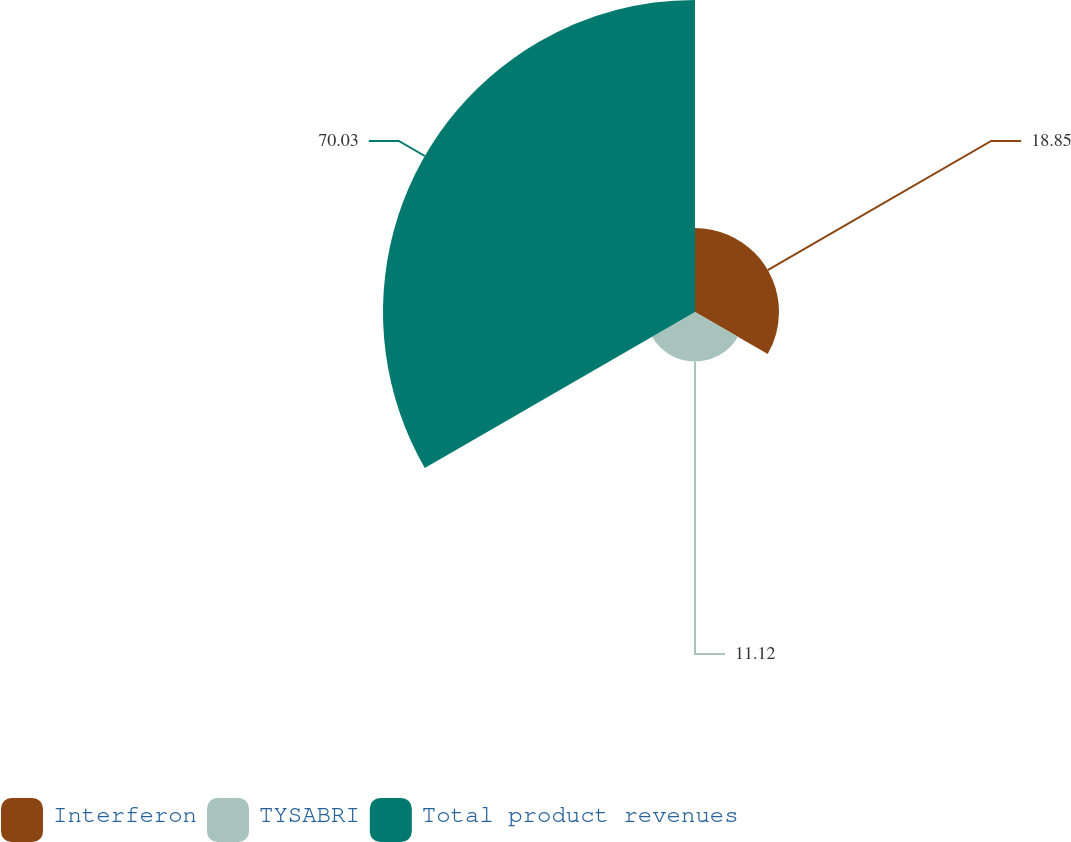Convert chart to OTSL. <chart><loc_0><loc_0><loc_500><loc_500><pie_chart><fcel>Interferon<fcel>TYSABRI<fcel>Total product revenues<nl><fcel>18.85%<fcel>11.12%<fcel>70.03%<nl></chart> 